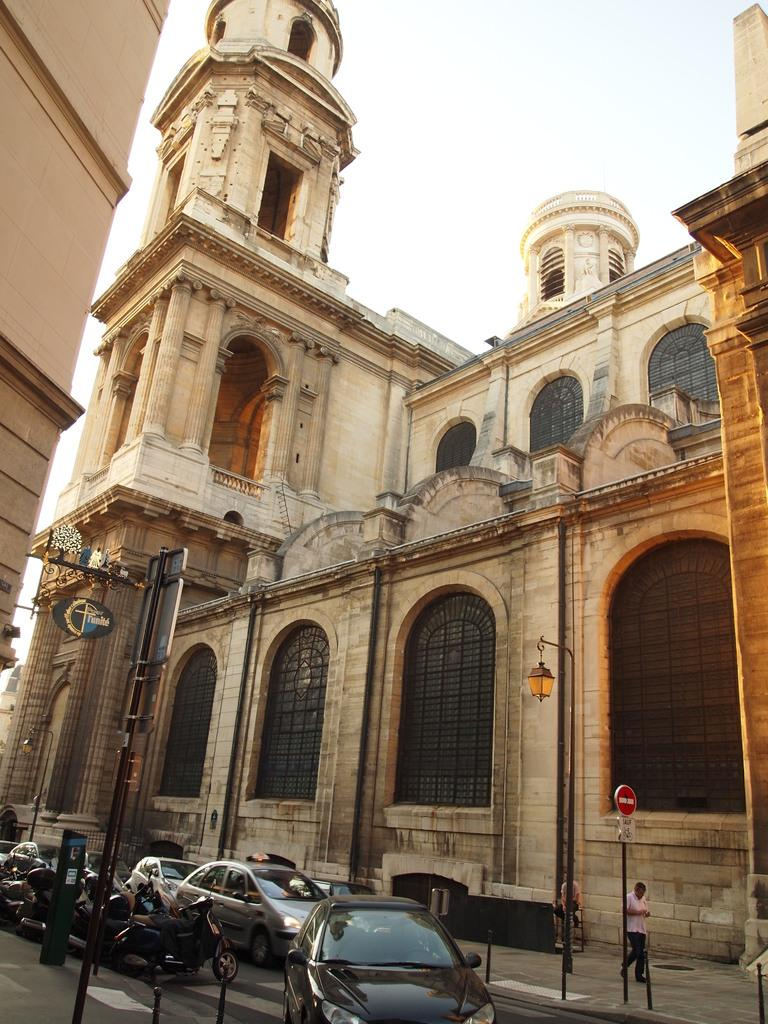What types of vehicles are in the foreground of the picture? There are cars and motorbikes in the foreground of the picture. What else can be seen in the foreground of the picture besides vehicles? There are sign boards and people in the foreground of the picture. What is the main feature of the foreground in the picture? There is a road in the foreground of the picture. What is visible in the center of the picture? There are buildings in the center of the picture. How would you describe the sky in the picture? The sky is cloudy in the picture. What type of ink is being used to write on the sign boards in the image? There is no indication of ink or writing on the sign boards in the image. How many sacks of zinc are visible in the image? There are no sacks of zinc present in the image. 